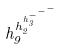<formula> <loc_0><loc_0><loc_500><loc_500>h _ { 9 } ^ { h _ { 2 } ^ { h _ { 3 } ^ { - ^ { - ^ { - } } } } }</formula> 